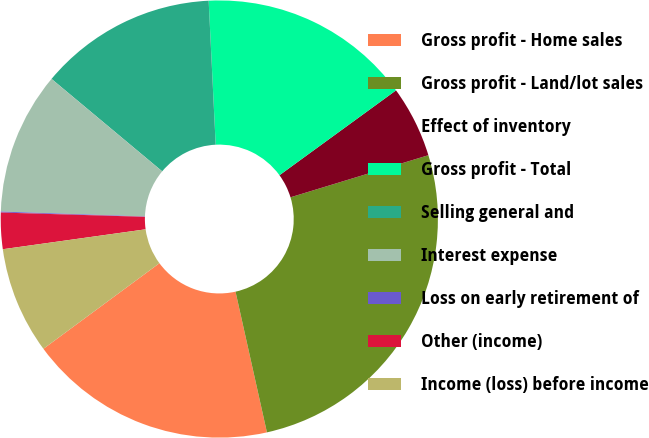Convert chart. <chart><loc_0><loc_0><loc_500><loc_500><pie_chart><fcel>Gross profit - Home sales<fcel>Gross profit - Land/lot sales<fcel>Effect of inventory<fcel>Gross profit - Total<fcel>Selling general and<fcel>Interest expense<fcel>Loss on early retirement of<fcel>Other (income)<fcel>Income (loss) before income<nl><fcel>18.38%<fcel>26.22%<fcel>5.3%<fcel>15.76%<fcel>13.15%<fcel>10.53%<fcel>0.07%<fcel>2.68%<fcel>7.91%<nl></chart> 